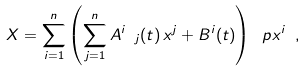<formula> <loc_0><loc_0><loc_500><loc_500>X = \sum _ { i = 1 } ^ { n } \left ( \sum _ { j = 1 } ^ { n } A ^ { i } \ _ { j } ( t ) \, x ^ { j } + B ^ { i } ( t ) \right ) \ p { x ^ { i } } \ ,</formula> 